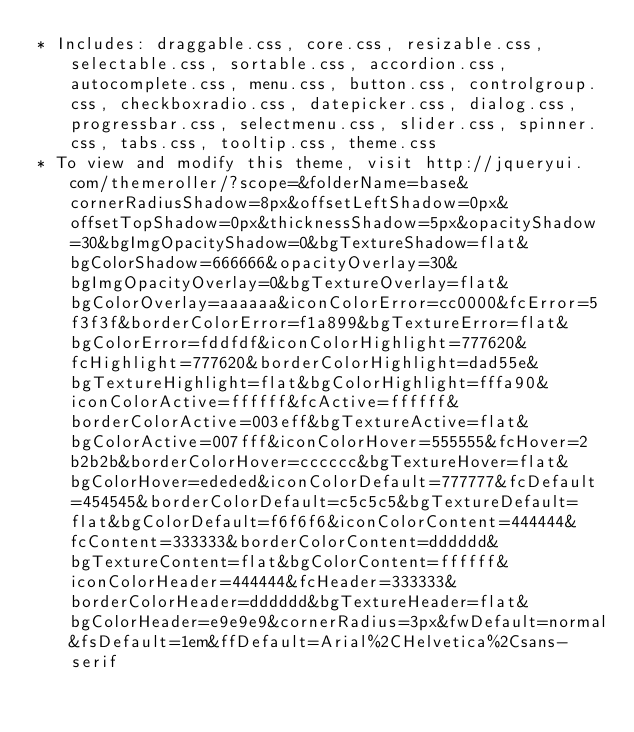<code> <loc_0><loc_0><loc_500><loc_500><_CSS_>* Includes: draggable.css, core.css, resizable.css, selectable.css, sortable.css, accordion.css, autocomplete.css, menu.css, button.css, controlgroup.css, checkboxradio.css, datepicker.css, dialog.css, progressbar.css, selectmenu.css, slider.css, spinner.css, tabs.css, tooltip.css, theme.css
* To view and modify this theme, visit http://jqueryui.com/themeroller/?scope=&folderName=base&cornerRadiusShadow=8px&offsetLeftShadow=0px&offsetTopShadow=0px&thicknessShadow=5px&opacityShadow=30&bgImgOpacityShadow=0&bgTextureShadow=flat&bgColorShadow=666666&opacityOverlay=30&bgImgOpacityOverlay=0&bgTextureOverlay=flat&bgColorOverlay=aaaaaa&iconColorError=cc0000&fcError=5f3f3f&borderColorError=f1a899&bgTextureError=flat&bgColorError=fddfdf&iconColorHighlight=777620&fcHighlight=777620&borderColorHighlight=dad55e&bgTextureHighlight=flat&bgColorHighlight=fffa90&iconColorActive=ffffff&fcActive=ffffff&borderColorActive=003eff&bgTextureActive=flat&bgColorActive=007fff&iconColorHover=555555&fcHover=2b2b2b&borderColorHover=cccccc&bgTextureHover=flat&bgColorHover=ededed&iconColorDefault=777777&fcDefault=454545&borderColorDefault=c5c5c5&bgTextureDefault=flat&bgColorDefault=f6f6f6&iconColorContent=444444&fcContent=333333&borderColorContent=dddddd&bgTextureContent=flat&bgColorContent=ffffff&iconColorHeader=444444&fcHeader=333333&borderColorHeader=dddddd&bgTextureHeader=flat&bgColorHeader=e9e9e9&cornerRadius=3px&fwDefault=normal&fsDefault=1em&ffDefault=Arial%2CHelvetica%2Csans-serif</code> 